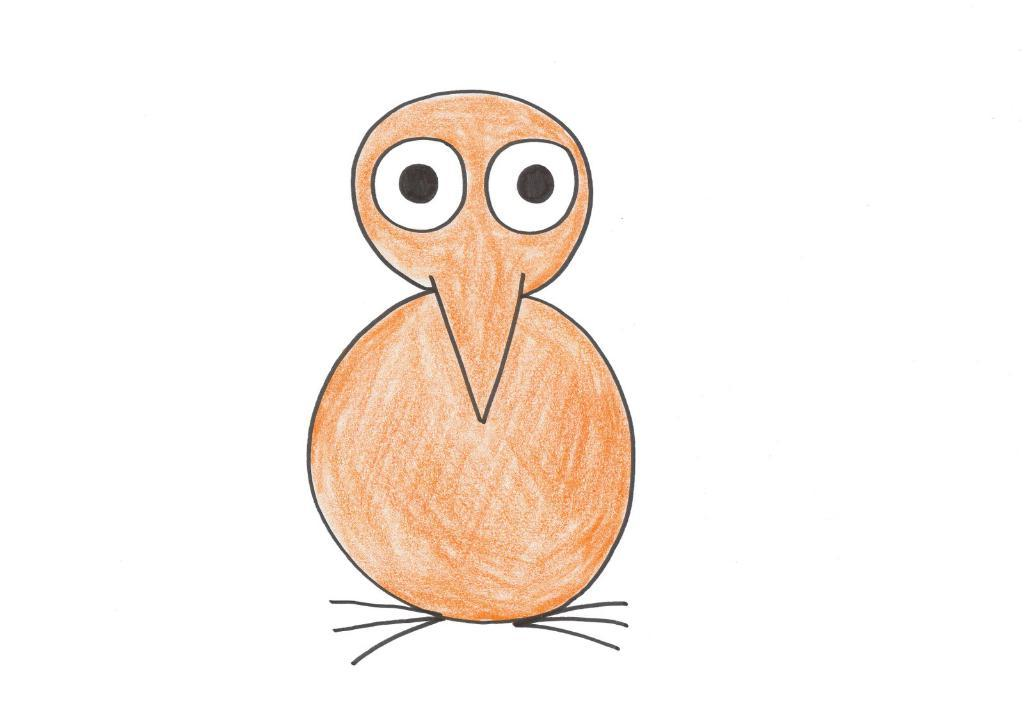What is the main subject of the painting? The painting depicts a bird. Can you describe the bird's facial features? The bird has two eyes and a nose. What body parts does the bird have for standing or walking? The bird has legs. What color is the background of the painting? The background of the painting is white. What historical event is depicted in the painting? The painting does not depict any historical event; it features a bird with specific facial features and body parts against a white background. Can you tell me the type of vase used to create the bird's legs in the painting? There is no vase used to create the bird's legs in the painting; the bird's legs are depicted as part of the bird's body. 